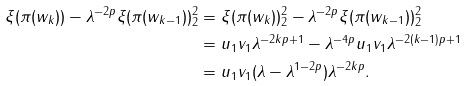Convert formula to latex. <formula><loc_0><loc_0><loc_500><loc_500>\| \xi ( \pi ( w _ { k } ) ) - \lambda ^ { - 2 p } \xi ( \pi ( w _ { k - 1 } ) ) \| ^ { 2 } _ { 2 } & = \| \xi ( \pi ( w _ { k } ) ) \| ^ { 2 } _ { 2 } - \| \lambda ^ { - 2 p } \xi ( \pi ( w _ { k - 1 } ) ) \| ^ { 2 } _ { 2 } \\ & = u _ { 1 } v _ { 1 } \lambda ^ { - 2 k p + 1 } - \lambda ^ { - 4 p } u _ { 1 } v _ { 1 } \lambda ^ { - 2 ( k - 1 ) p + 1 } \\ & = u _ { 1 } v _ { 1 } ( \lambda - \lambda ^ { 1 - 2 p } ) \lambda ^ { - 2 k p } .</formula> 